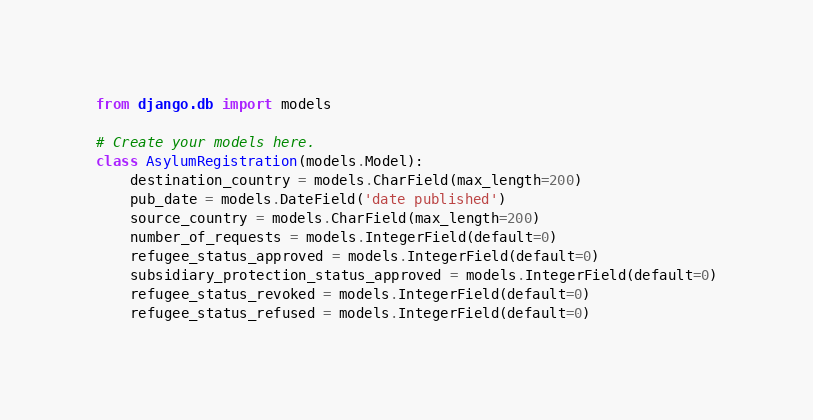<code> <loc_0><loc_0><loc_500><loc_500><_Python_>from django.db import models

# Create your models here.
class AsylumRegistration(models.Model):
    destination_country = models.CharField(max_length=200)
    pub_date = models.DateField('date published')
    source_country = models.CharField(max_length=200)
    number_of_requests = models.IntegerField(default=0)
    refugee_status_approved = models.IntegerField(default=0)
    subsidiary_protection_status_approved = models.IntegerField(default=0)
    refugee_status_revoked = models.IntegerField(default=0)
    refugee_status_refused = models.IntegerField(default=0)
</code> 